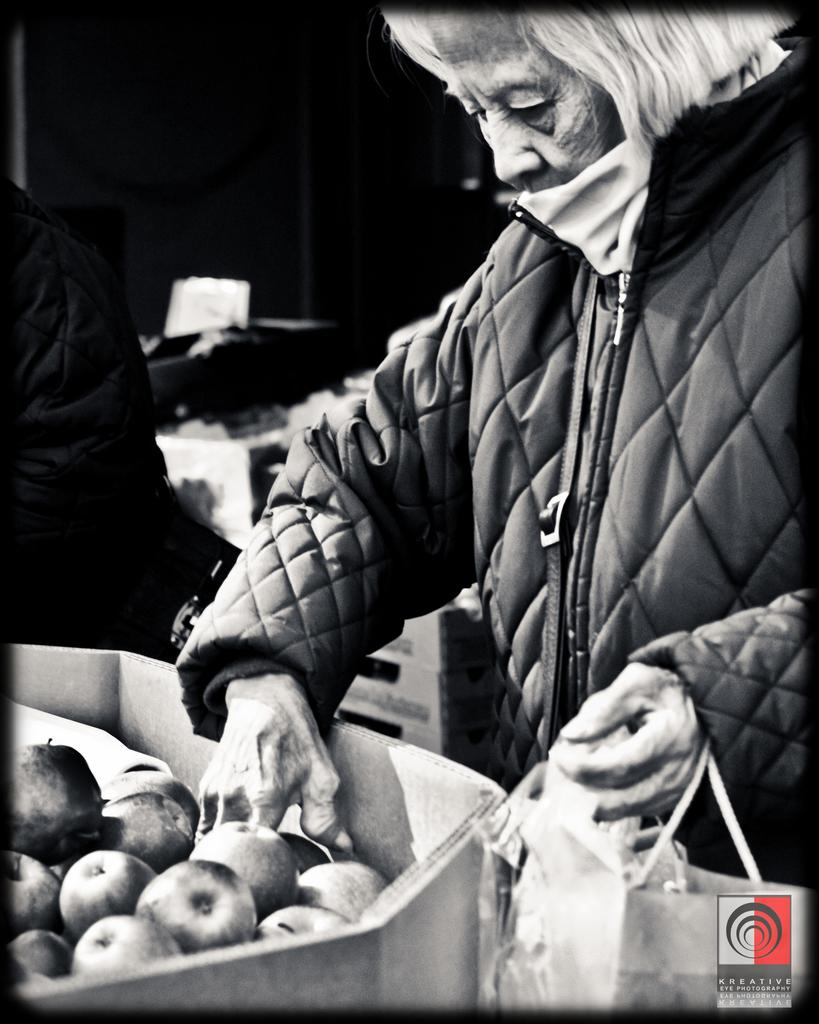How many people are in the image? There are people in the image, but the exact number is not specified. What are the people wearing in the image? The people are wearing coats in the image. What is one person holding in the image? One person is holding a bag in the image. What type of food can be seen in the image? There are fruits in a box in the image. What can be found at the bottom of the image? There is a logo at the bottom of the image. What type of quarter is depicted in the image? There is no quarter depicted in the image. What plot of land is visible in the image? There is no plot of land visible in the image. 